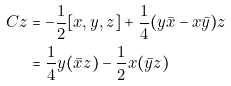Convert formula to latex. <formula><loc_0><loc_0><loc_500><loc_500>C z & = - \frac { 1 } { 2 } [ x , y , z ] + \frac { 1 } { 4 } ( y \bar { x } - x \bar { y } ) z \\ & = \frac { 1 } { 4 } y ( \bar { x } z ) - \frac { 1 } { 2 } x ( \bar { y } z )</formula> 